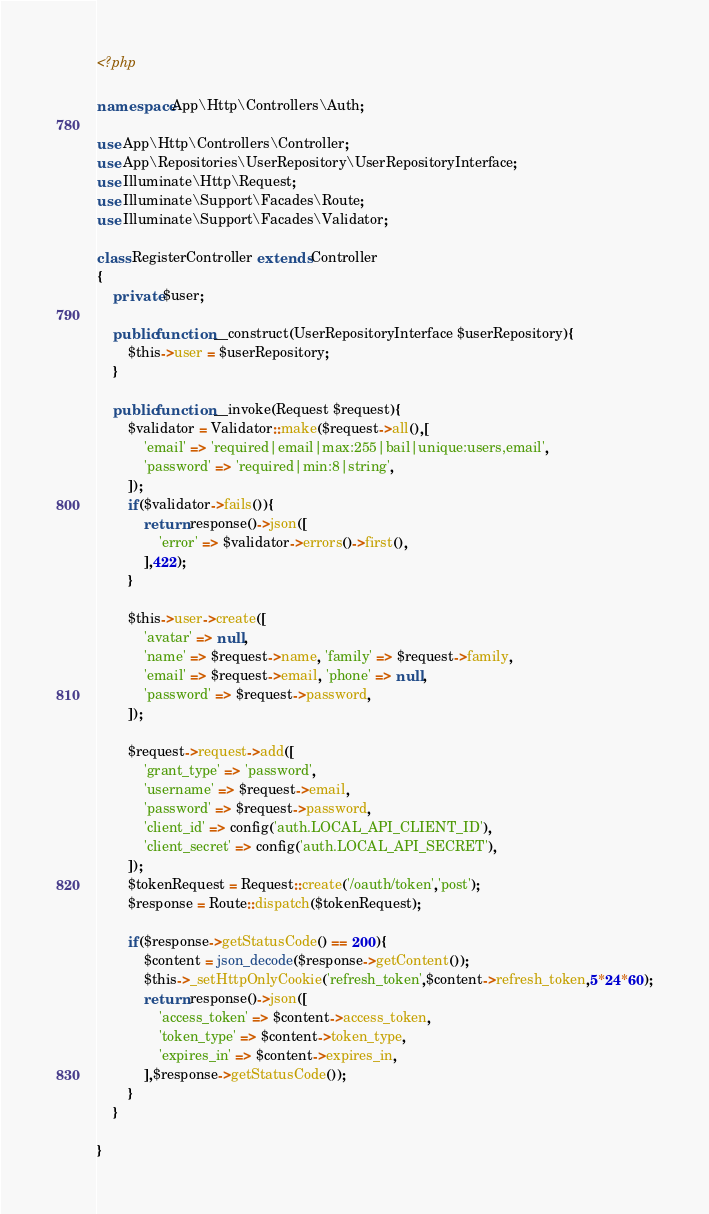<code> <loc_0><loc_0><loc_500><loc_500><_PHP_><?php

namespace App\Http\Controllers\Auth;

use App\Http\Controllers\Controller;
use App\Repositories\UserRepository\UserRepositoryInterface;
use Illuminate\Http\Request;
use Illuminate\Support\Facades\Route;
use Illuminate\Support\Facades\Validator;

class RegisterController extends Controller
{
    private $user;

    public function __construct(UserRepositoryInterface $userRepository){
        $this->user = $userRepository;
    }

    public function __invoke(Request $request){
        $validator = Validator::make($request->all(),[
            'email' => 'required|email|max:255|bail|unique:users,email',
            'password' => 'required|min:8|string',
        ]);
        if($validator->fails()){
            return response()->json([
                'error' => $validator->errors()->first(),
            ],422);
        }

        $this->user->create([
            'avatar' => null,
            'name' => $request->name, 'family' => $request->family,
            'email' => $request->email, 'phone' => null,
            'password' => $request->password,
        ]);

        $request->request->add([
            'grant_type' => 'password',
            'username' => $request->email,
            'password' => $request->password,
            'client_id' => config('auth.LOCAL_API_CLIENT_ID'),
            'client_secret' => config('auth.LOCAL_API_SECRET'),
        ]);
        $tokenRequest = Request::create('/oauth/token','post');
        $response = Route::dispatch($tokenRequest);

        if($response->getStatusCode() == 200){
            $content = json_decode($response->getContent());
            $this->_setHttpOnlyCookie('refresh_token',$content->refresh_token,5*24*60);
            return response()->json([
                'access_token' => $content->access_token,
                'token_type' => $content->token_type,
                'expires_in' => $content->expires_in,
            ],$response->getStatusCode());
        }
    }

}
</code> 